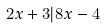Convert formula to latex. <formula><loc_0><loc_0><loc_500><loc_500>2 x + 3 | 8 x - 4</formula> 